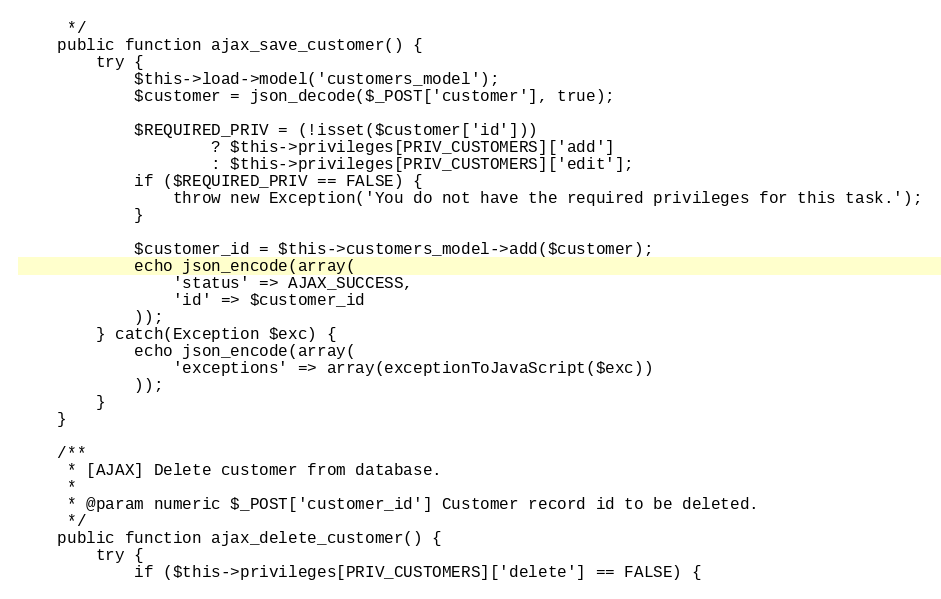<code> <loc_0><loc_0><loc_500><loc_500><_PHP_>     */
    public function ajax_save_customer() {
        try {
            $this->load->model('customers_model');
            $customer = json_decode($_POST['customer'], true);

            $REQUIRED_PRIV = (!isset($customer['id']))
                    ? $this->privileges[PRIV_CUSTOMERS]['add']
                    : $this->privileges[PRIV_CUSTOMERS]['edit'];
            if ($REQUIRED_PRIV == FALSE) {
                throw new Exception('You do not have the required privileges for this task.');
            }

            $customer_id = $this->customers_model->add($customer);
            echo json_encode(array(
                'status' => AJAX_SUCCESS,
                'id' => $customer_id
            ));
        } catch(Exception $exc) {
            echo json_encode(array(
                'exceptions' => array(exceptionToJavaScript($exc))
            ));
        }
    }

    /**
     * [AJAX] Delete customer from database.
     *
     * @param numeric $_POST['customer_id'] Customer record id to be deleted.
     */
    public function ajax_delete_customer() {
        try {
            if ($this->privileges[PRIV_CUSTOMERS]['delete'] == FALSE) {</code> 